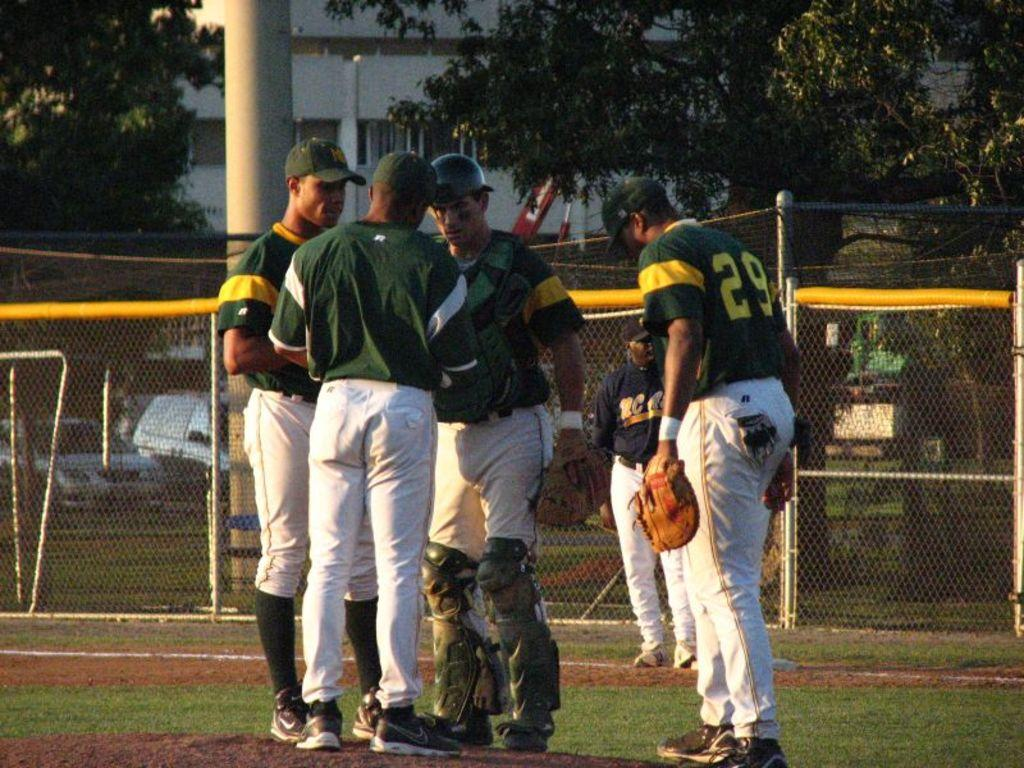<image>
Offer a succinct explanation of the picture presented. Baseball player number 29 standing in a huddle with other players. 